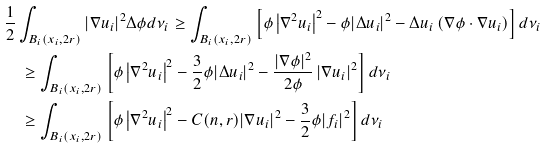Convert formula to latex. <formula><loc_0><loc_0><loc_500><loc_500>& \frac { 1 } { 2 } \int _ { B _ { i } ( x _ { i } , 2 r ) } | \nabla u _ { i } | ^ { 2 } \Delta \phi d \nu _ { i } \geq \int _ { B _ { i } ( x _ { i } , 2 r ) } \left [ \phi \left | \nabla ^ { 2 } u _ { i } \right | ^ { 2 } - \phi | \Delta u _ { i } | ^ { 2 } - \Delta u _ { i } \left ( \nabla \phi \cdot \nabla u _ { i } \right ) \right ] d \nu _ { i } \\ & \quad \geq \int _ { B _ { i } ( x _ { i } , 2 r ) } \left [ \phi \left | \nabla ^ { 2 } u _ { i } \right | ^ { 2 } - \frac { 3 } { 2 } \phi | \Delta u _ { i } | ^ { 2 } - \frac { | \nabla \phi | ^ { 2 } } { 2 \phi } \left | \nabla u _ { i } \right | ^ { 2 } \right ] d \nu _ { i } \\ & \quad \geq \int _ { B _ { i } ( x _ { i } , 2 r ) } \left [ \phi \left | \nabla ^ { 2 } u _ { i } \right | ^ { 2 } - C ( n , r ) | \nabla u _ { i } | ^ { 2 } - \frac { 3 } { 2 } \phi | f _ { i } | ^ { 2 } \right ] d \nu _ { i }</formula> 